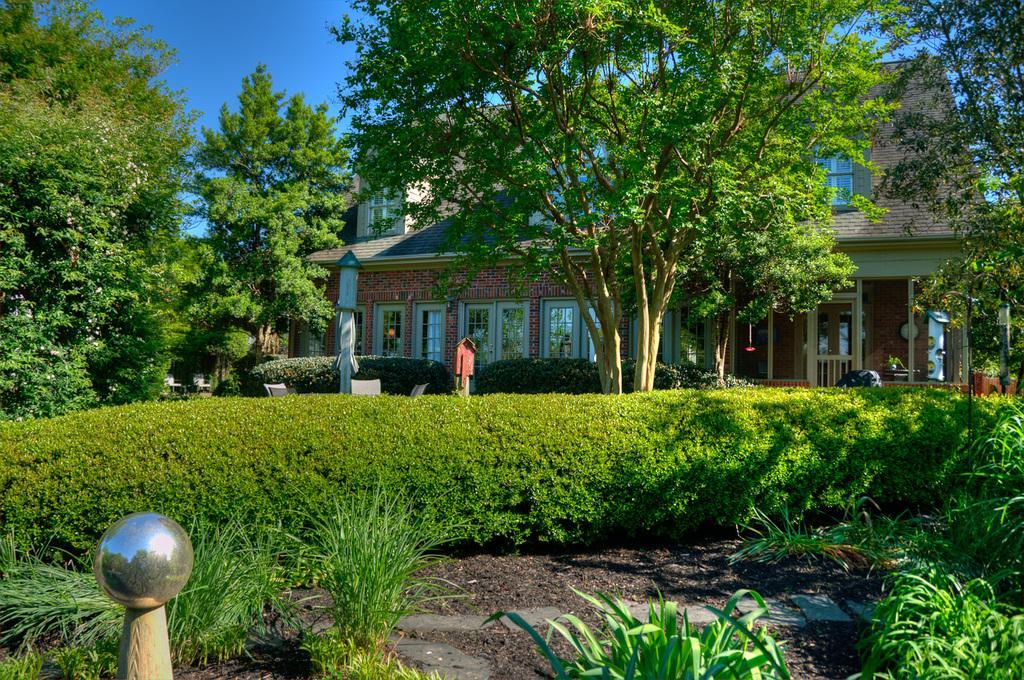Describe this image in one or two sentences. This picture is clicked outside. In the foreground we can see the grass, a metal object, plants, trees and chairs. In the center there is a house and we can see the doors and windows of the house. In the background there is a sky. 